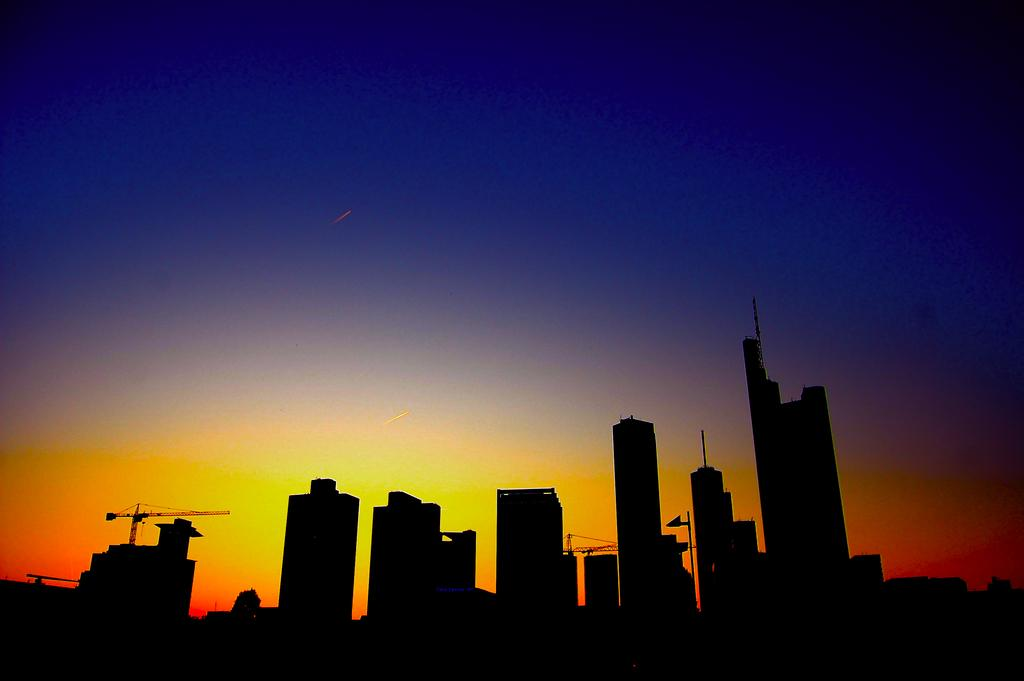What type of structures can be seen in the image? There are buildings in the image. What construction equipment is present in the image? There is a tower crane in the image. What part of the natural environment is visible in the image? The sky is visible in the image. What is the behavior of the park in the image? There is no park present in the image, so it is not possible to determine its behavior. 